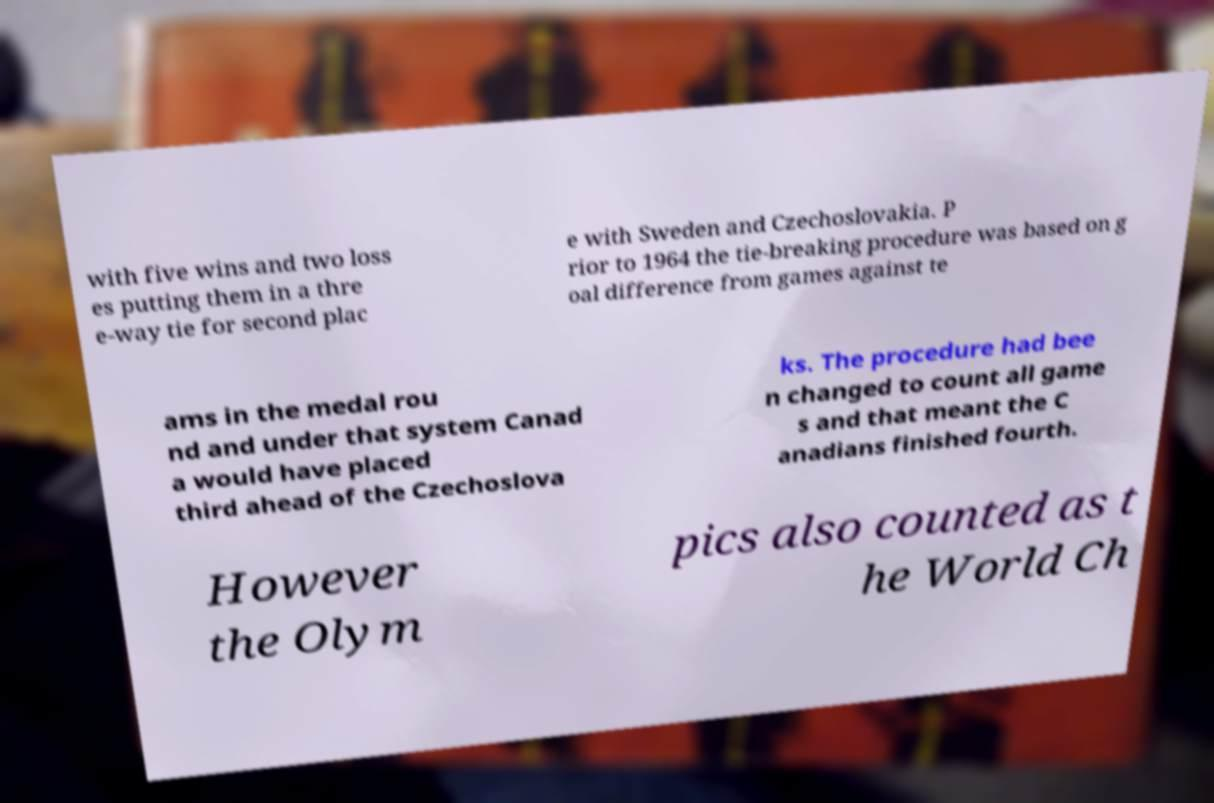Could you extract and type out the text from this image? with five wins and two loss es putting them in a thre e-way tie for second plac e with Sweden and Czechoslovakia. P rior to 1964 the tie-breaking procedure was based on g oal difference from games against te ams in the medal rou nd and under that system Canad a would have placed third ahead of the Czechoslova ks. The procedure had bee n changed to count all game s and that meant the C anadians finished fourth. However the Olym pics also counted as t he World Ch 